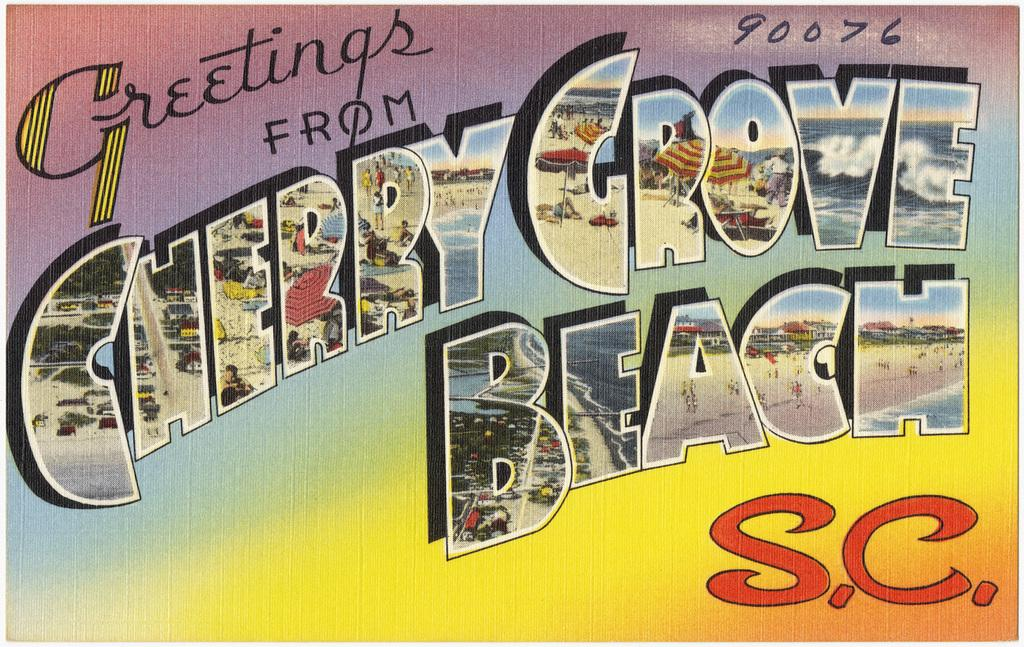<image>
Relay a brief, clear account of the picture shown. A postcard with Greetings fro Cherry Grove Beach. 